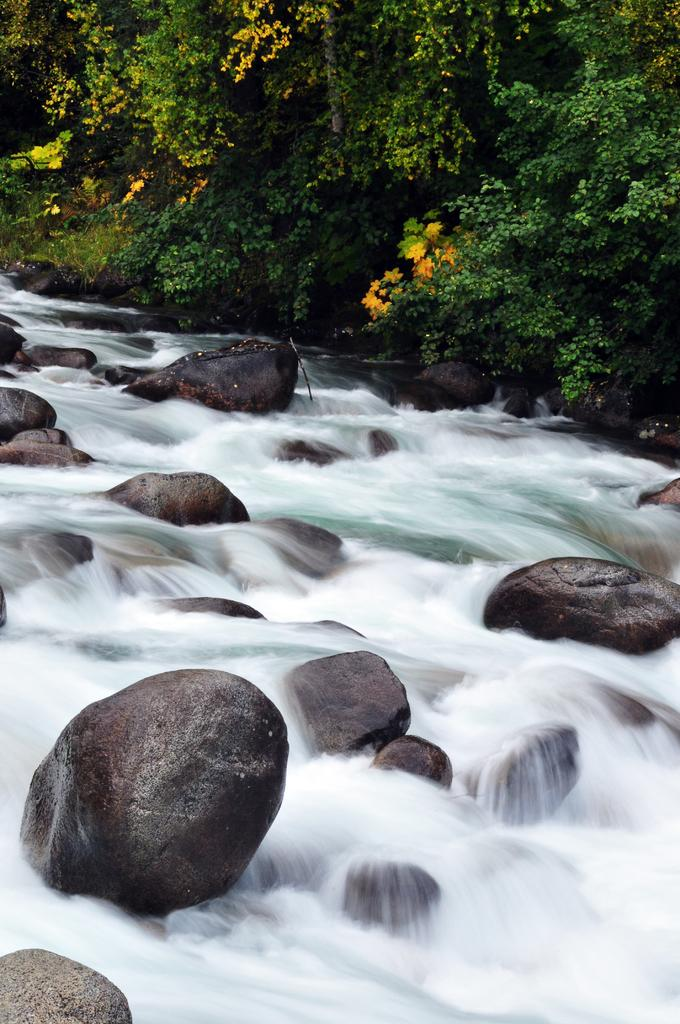What type of natural elements can be seen in the image? There are trees and rocks in the image. What is the water doing in the image? There is water flowing in the image. Can you see a zebra combing its mane near the rocks in the image? No, there is no zebra or comb present in the image. 